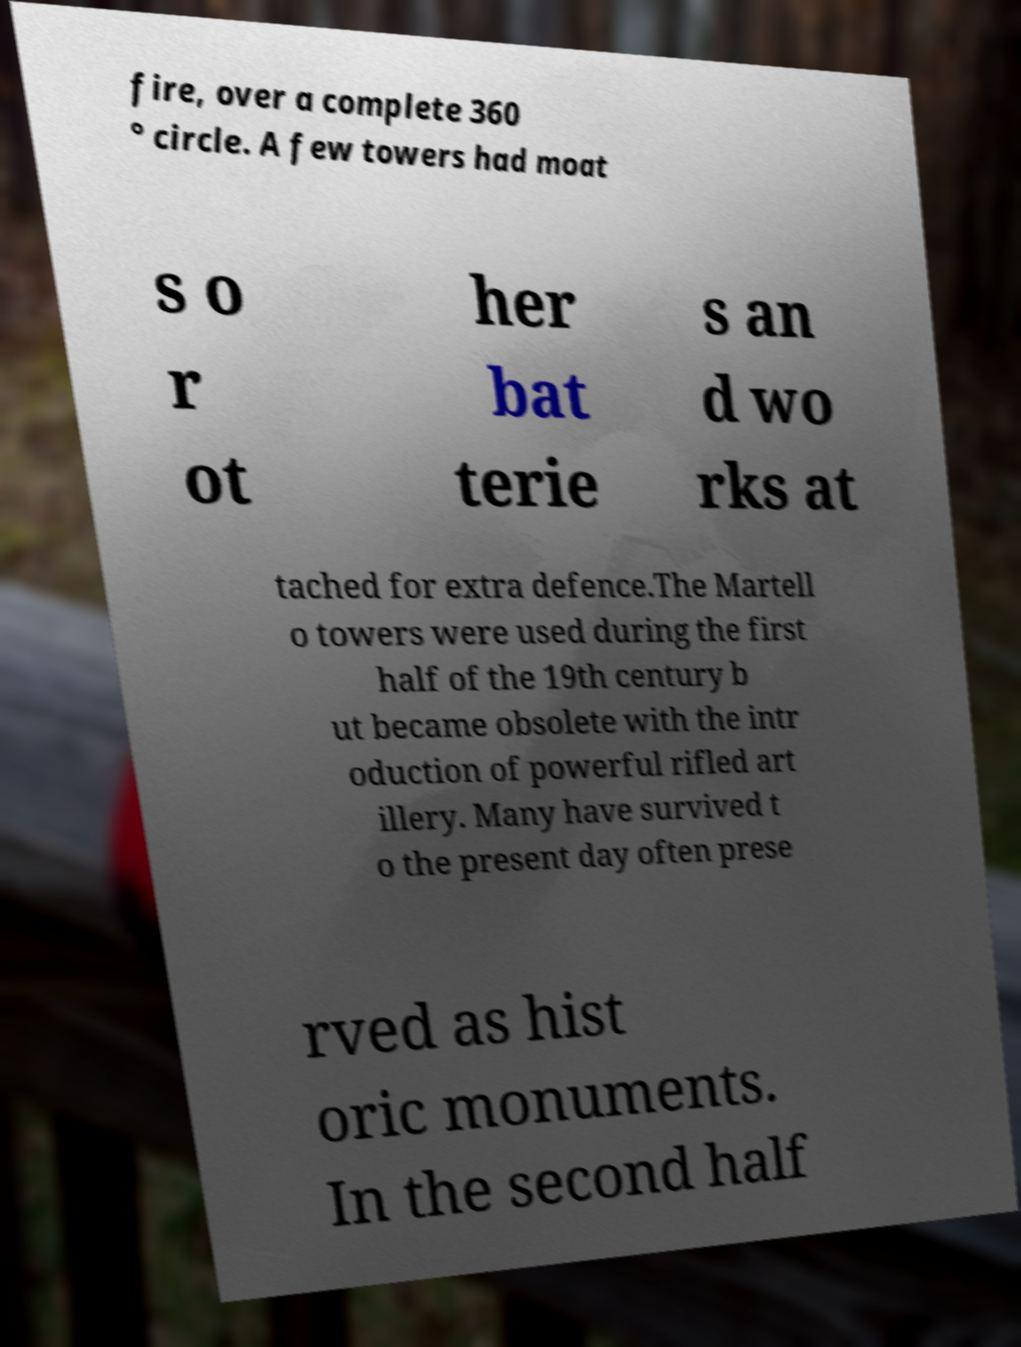I need the written content from this picture converted into text. Can you do that? fire, over a complete 360 ° circle. A few towers had moat s o r ot her bat terie s an d wo rks at tached for extra defence.The Martell o towers were used during the first half of the 19th century b ut became obsolete with the intr oduction of powerful rifled art illery. Many have survived t o the present day often prese rved as hist oric monuments. In the second half 